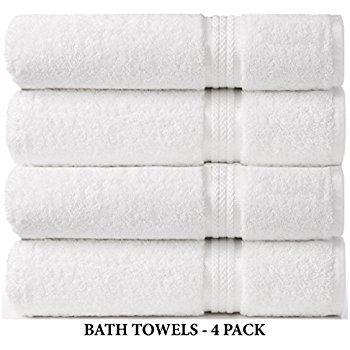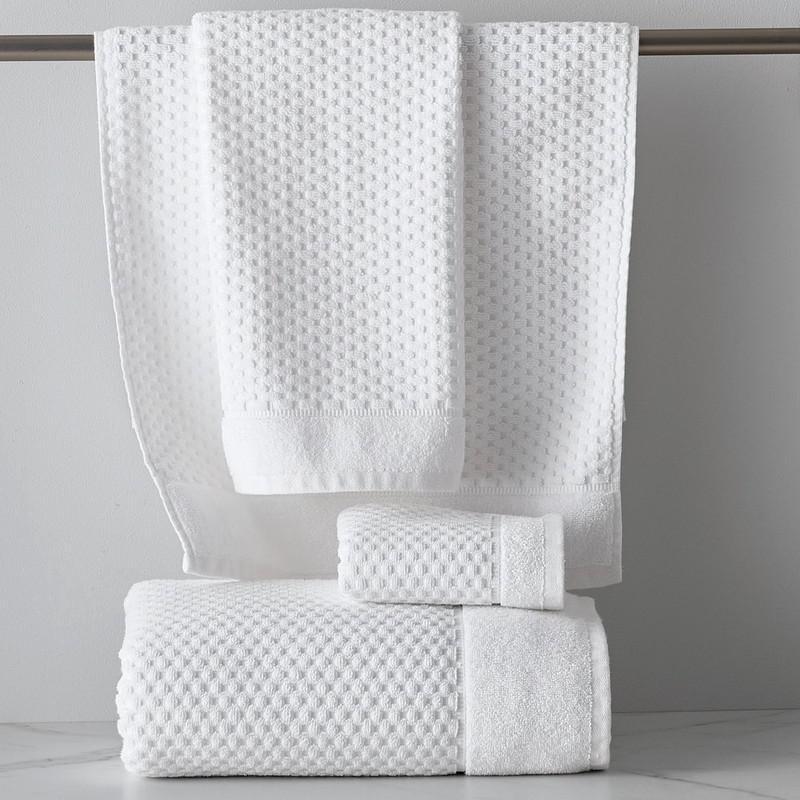The first image is the image on the left, the second image is the image on the right. Analyze the images presented: Is the assertion "the right image has 4 neatly folded and stacked bath towels" valid? Answer yes or no. No. The first image is the image on the left, the second image is the image on the right. Given the left and right images, does the statement "In one of the images, there are towels that are not folded or rolled." hold true? Answer yes or no. Yes. 